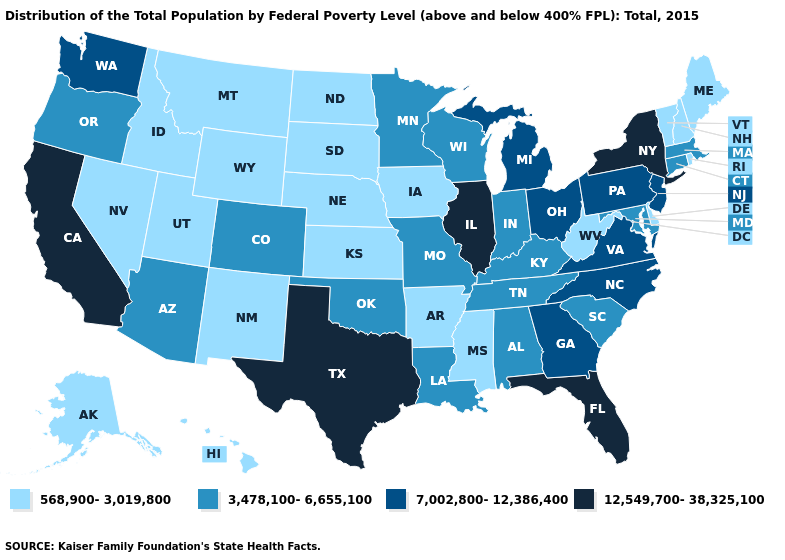Among the states that border Oregon , which have the lowest value?
Keep it brief. Idaho, Nevada. Name the states that have a value in the range 568,900-3,019,800?
Write a very short answer. Alaska, Arkansas, Delaware, Hawaii, Idaho, Iowa, Kansas, Maine, Mississippi, Montana, Nebraska, Nevada, New Hampshire, New Mexico, North Dakota, Rhode Island, South Dakota, Utah, Vermont, West Virginia, Wyoming. Among the states that border Nevada , which have the lowest value?
Give a very brief answer. Idaho, Utah. What is the lowest value in the USA?
Give a very brief answer. 568,900-3,019,800. Name the states that have a value in the range 12,549,700-38,325,100?
Answer briefly. California, Florida, Illinois, New York, Texas. Name the states that have a value in the range 12,549,700-38,325,100?
Keep it brief. California, Florida, Illinois, New York, Texas. What is the highest value in states that border Oregon?
Keep it brief. 12,549,700-38,325,100. Name the states that have a value in the range 7,002,800-12,386,400?
Write a very short answer. Georgia, Michigan, New Jersey, North Carolina, Ohio, Pennsylvania, Virginia, Washington. Among the states that border Indiana , does Michigan have the lowest value?
Be succinct. No. Which states have the lowest value in the USA?
Be succinct. Alaska, Arkansas, Delaware, Hawaii, Idaho, Iowa, Kansas, Maine, Mississippi, Montana, Nebraska, Nevada, New Hampshire, New Mexico, North Dakota, Rhode Island, South Dakota, Utah, Vermont, West Virginia, Wyoming. Does the first symbol in the legend represent the smallest category?
Quick response, please. Yes. What is the value of Illinois?
Be succinct. 12,549,700-38,325,100. Among the states that border Utah , does Colorado have the highest value?
Concise answer only. Yes. Name the states that have a value in the range 568,900-3,019,800?
Answer briefly. Alaska, Arkansas, Delaware, Hawaii, Idaho, Iowa, Kansas, Maine, Mississippi, Montana, Nebraska, Nevada, New Hampshire, New Mexico, North Dakota, Rhode Island, South Dakota, Utah, Vermont, West Virginia, Wyoming. Does Arizona have a lower value than Wyoming?
Concise answer only. No. 